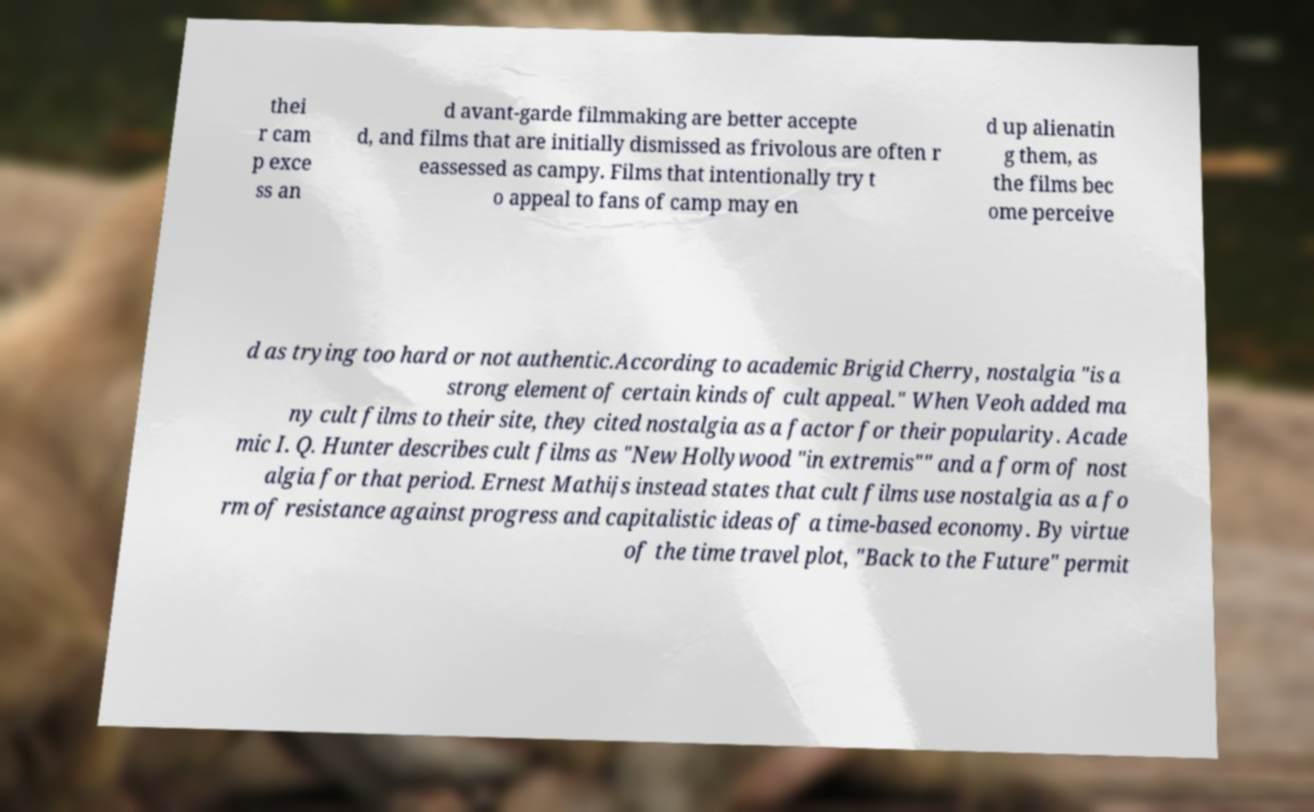What messages or text are displayed in this image? I need them in a readable, typed format. thei r cam p exce ss an d avant-garde filmmaking are better accepte d, and films that are initially dismissed as frivolous are often r eassessed as campy. Films that intentionally try t o appeal to fans of camp may en d up alienatin g them, as the films bec ome perceive d as trying too hard or not authentic.According to academic Brigid Cherry, nostalgia "is a strong element of certain kinds of cult appeal." When Veoh added ma ny cult films to their site, they cited nostalgia as a factor for their popularity. Acade mic I. Q. Hunter describes cult films as "New Hollywood "in extremis"" and a form of nost algia for that period. Ernest Mathijs instead states that cult films use nostalgia as a fo rm of resistance against progress and capitalistic ideas of a time-based economy. By virtue of the time travel plot, "Back to the Future" permit 